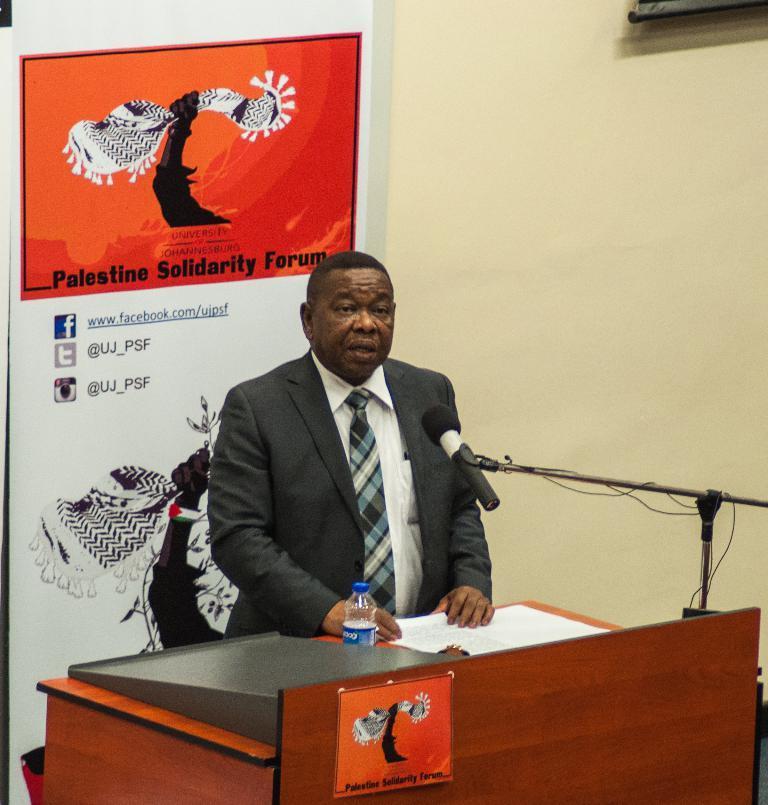In one or two sentences, can you explain what this image depicts? In the center we can see one man he is speaking something, which we can see on his face his mouth is open. In front of him there is a microphone and some wood table stand. On table there is a water bottle, and back of them there is a banner. 